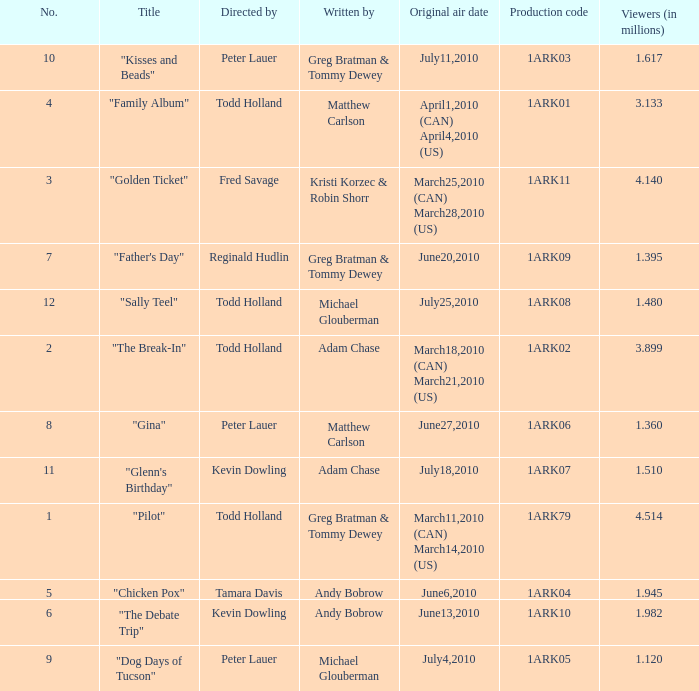List all who wrote for production code 1ark07. Adam Chase. 